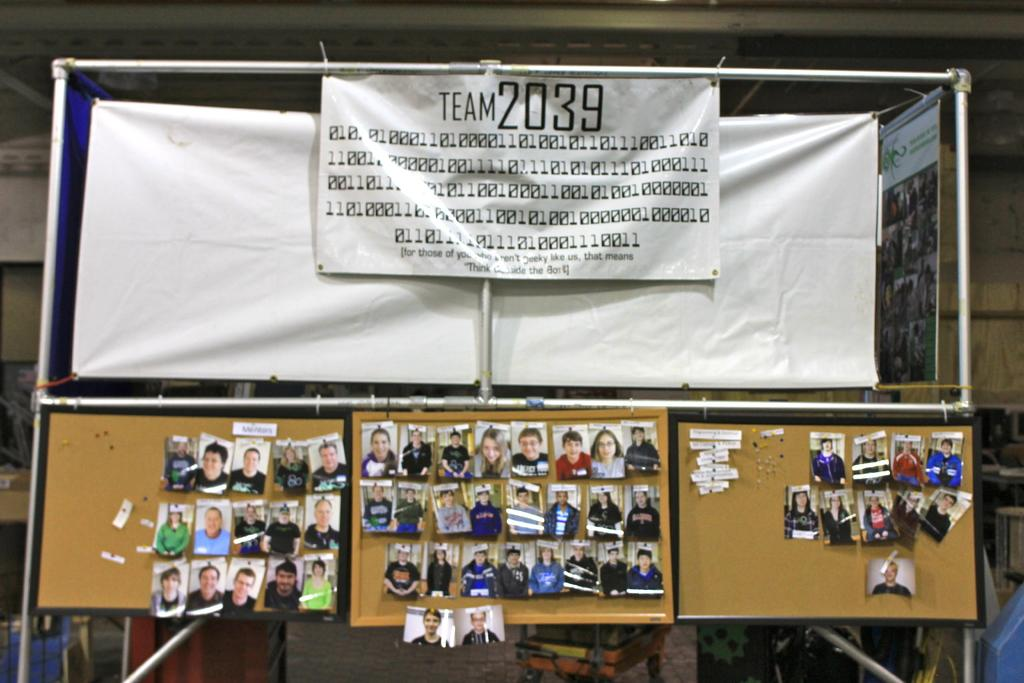Provide a one-sentence caption for the provided image. a bulletin board with pictures of team 2039 on the banner.. 